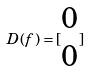Convert formula to latex. <formula><loc_0><loc_0><loc_500><loc_500>D ( f ) = [ \begin{matrix} 0 \\ 0 \end{matrix} ]</formula> 